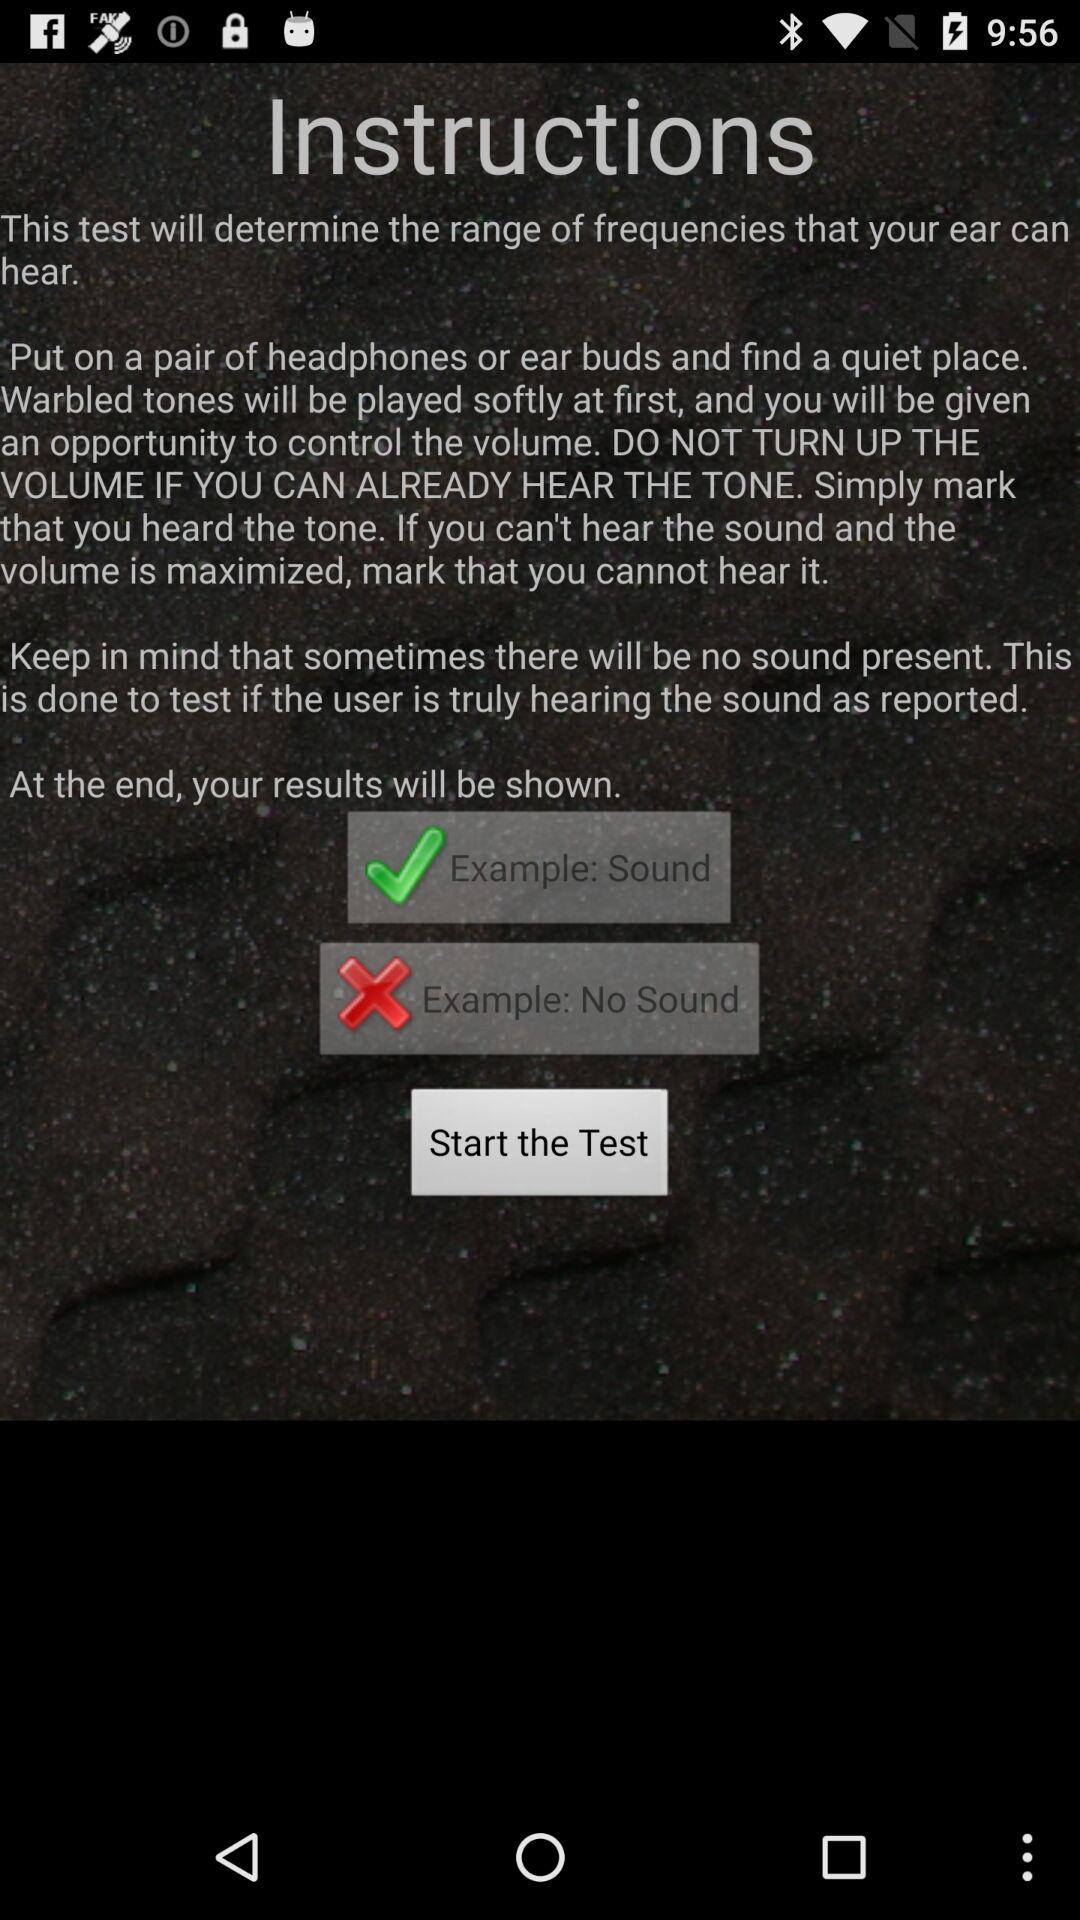How many examples are there in the instructions?
Answer the question using a single word or phrase. 2 